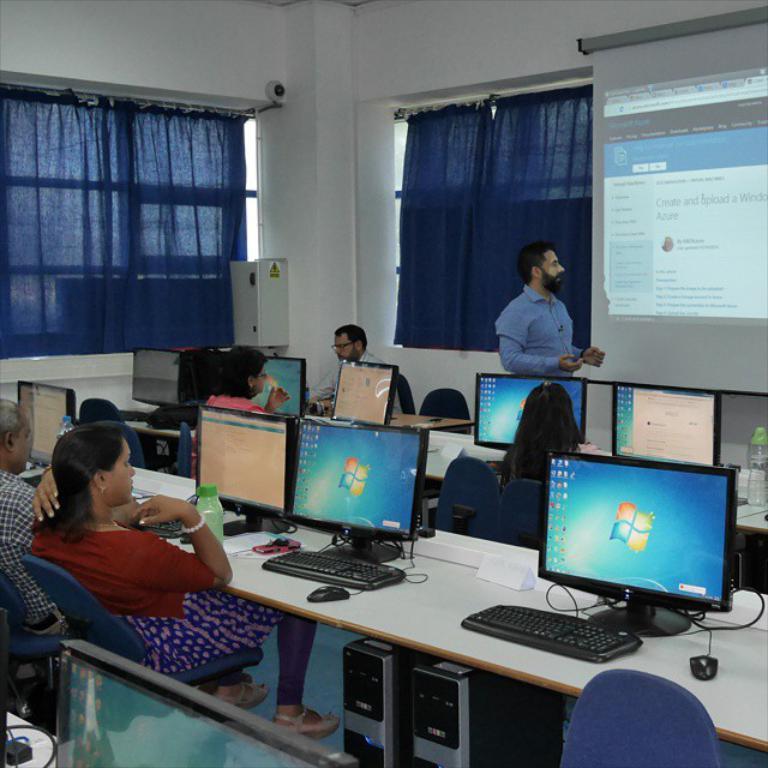Please provide a concise description of this image. In this picture we can see some persons are sitting on the chairs. This is table. On the table there are monitors, keyboards, and mouse. On the background there is a wall and this is curtain. Here we can see a screen. 